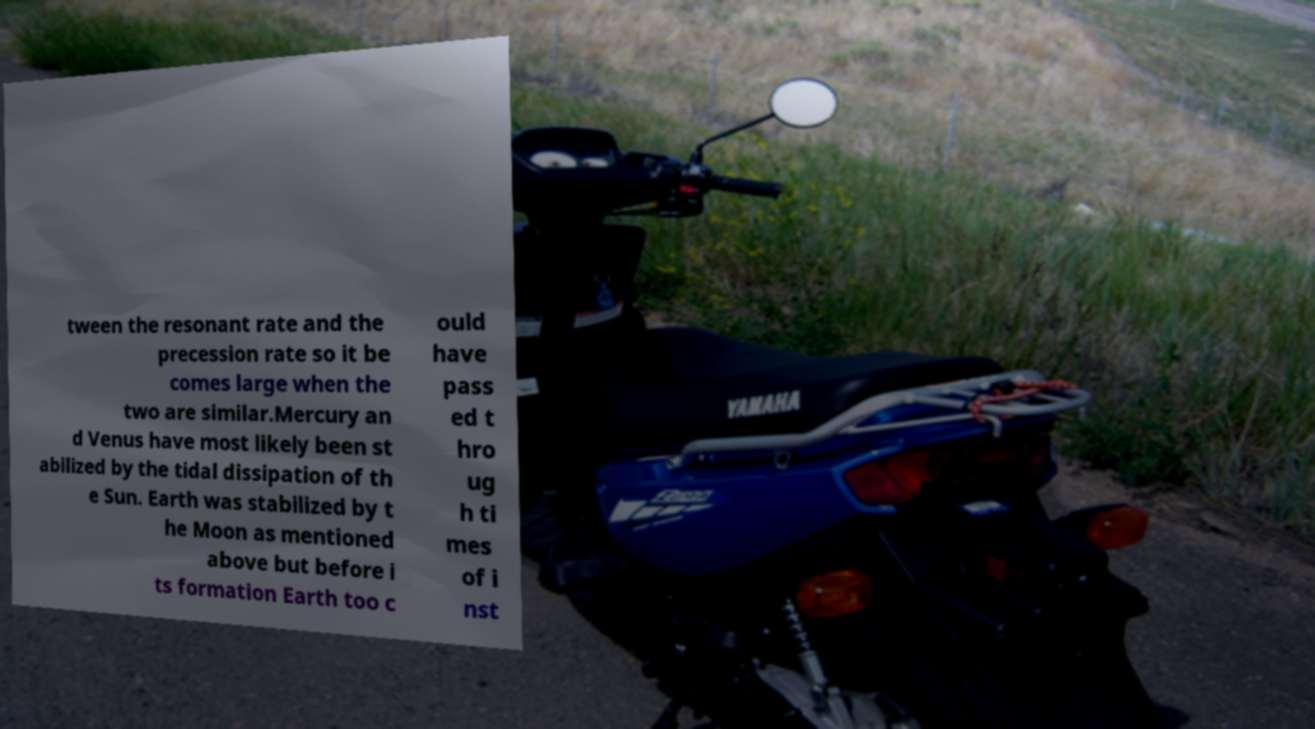Can you accurately transcribe the text from the provided image for me? tween the resonant rate and the precession rate so it be comes large when the two are similar.Mercury an d Venus have most likely been st abilized by the tidal dissipation of th e Sun. Earth was stabilized by t he Moon as mentioned above but before i ts formation Earth too c ould have pass ed t hro ug h ti mes of i nst 